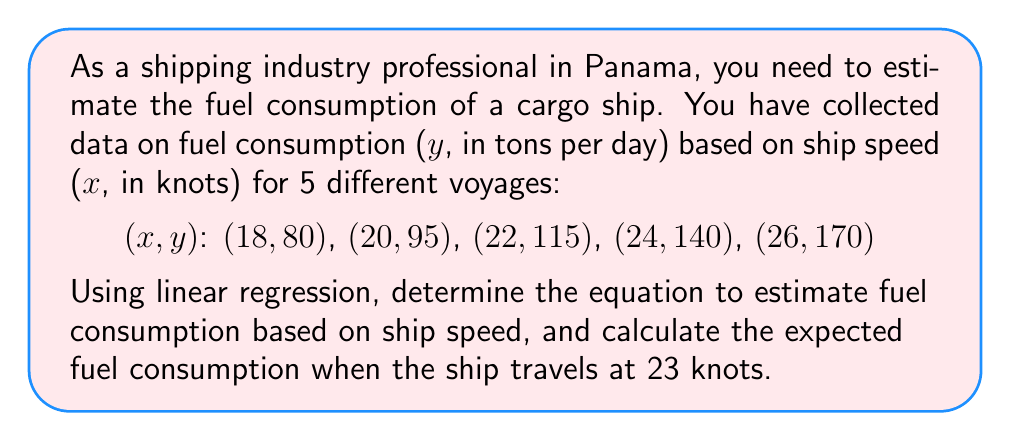Teach me how to tackle this problem. To solve this problem, we'll use linear regression to find the line of best fit for the given data points. Then we'll use the resulting equation to estimate fuel consumption at 23 knots.

Step 1: Calculate the required sums for linear regression.
$$n = 5$$
$$\sum x = 18 + 20 + 22 + 24 + 26 = 110$$
$$\sum y = 80 + 95 + 115 + 140 + 170 = 600$$
$$\sum xy = (18)(80) + (20)(95) + (22)(115) + (24)(140) + (26)(170) = 13,850$$
$$\sum x^2 = 18^2 + 20^2 + 22^2 + 24^2 + 26^2 = 2,460$$

Step 2: Calculate the slope (m) using the formula:
$$m = \frac{n\sum xy - \sum x \sum y}{n\sum x^2 - (\sum x)^2}$$
$$m = \frac{5(13,850) - 110(600)}{5(2,460) - 110^2} = \frac{69,250 - 66,000}{12,300 - 12,100} = \frac{3,250}{200} = 16.25$$

Step 3: Calculate the y-intercept (b) using the formula:
$$b = \frac{\sum y - m\sum x}{n}$$
$$b = \frac{600 - 16.25(110)}{5} = \frac{600 - 1,787.5}{5} = -237.5$$

Step 4: Write the linear regression equation:
$$y = mx + b$$
$$y = 16.25x - 237.5$$

Step 5: Estimate fuel consumption at 23 knots by plugging x = 23 into the equation:
$$y = 16.25(23) - 237.5 = 373.75 - 237.5 = 136.25$$

Therefore, the estimated fuel consumption at 23 knots is 136.25 tons per day.
Answer: y = 16.25x - 237.5; 136.25 tons/day at 23 knots 